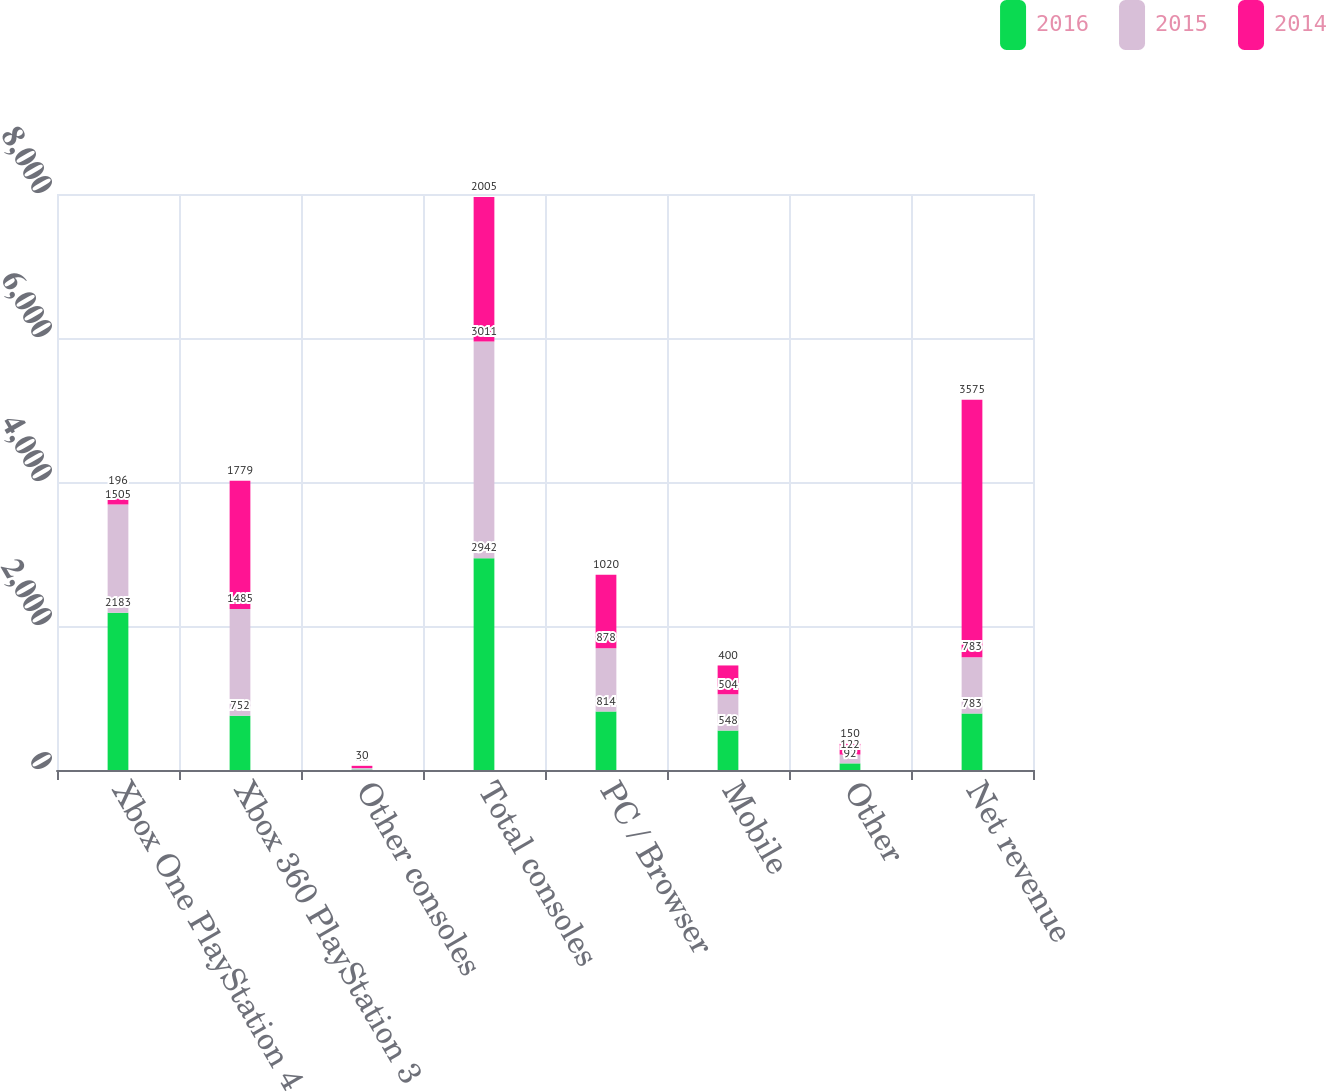<chart> <loc_0><loc_0><loc_500><loc_500><stacked_bar_chart><ecel><fcel>Xbox One PlayStation 4<fcel>Xbox 360 PlayStation 3<fcel>Other consoles<fcel>Total consoles<fcel>PC / Browser<fcel>Mobile<fcel>Other<fcel>Net revenue<nl><fcel>2016<fcel>2183<fcel>752<fcel>7<fcel>2942<fcel>814<fcel>548<fcel>92<fcel>783<nl><fcel>2015<fcel>1505<fcel>1485<fcel>21<fcel>3011<fcel>878<fcel>504<fcel>122<fcel>783<nl><fcel>2014<fcel>196<fcel>1779<fcel>30<fcel>2005<fcel>1020<fcel>400<fcel>150<fcel>3575<nl></chart> 